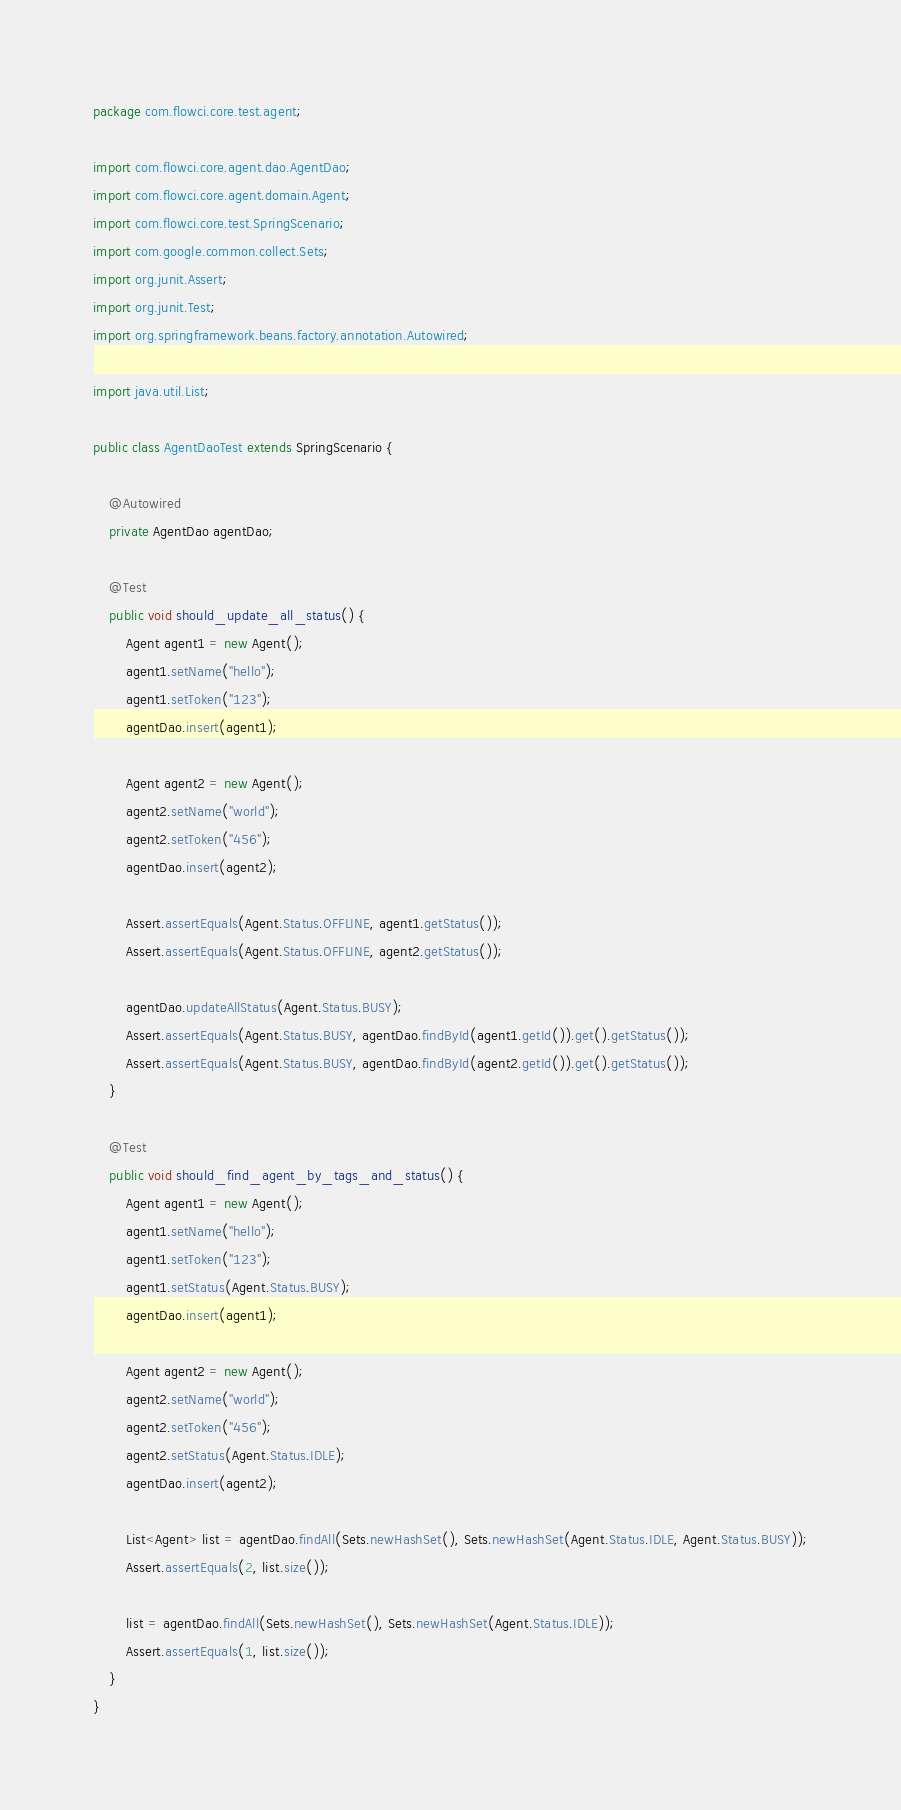Convert code to text. <code><loc_0><loc_0><loc_500><loc_500><_Java_>package com.flowci.core.test.agent;

import com.flowci.core.agent.dao.AgentDao;
import com.flowci.core.agent.domain.Agent;
import com.flowci.core.test.SpringScenario;
import com.google.common.collect.Sets;
import org.junit.Assert;
import org.junit.Test;
import org.springframework.beans.factory.annotation.Autowired;

import java.util.List;

public class AgentDaoTest extends SpringScenario {

    @Autowired
    private AgentDao agentDao;

    @Test
    public void should_update_all_status() {
        Agent agent1 = new Agent();
        agent1.setName("hello");
        agent1.setToken("123");
        agentDao.insert(agent1);

        Agent agent2 = new Agent();
        agent2.setName("world");
        agent2.setToken("456");
        agentDao.insert(agent2);

        Assert.assertEquals(Agent.Status.OFFLINE, agent1.getStatus());
        Assert.assertEquals(Agent.Status.OFFLINE, agent2.getStatus());

        agentDao.updateAllStatus(Agent.Status.BUSY);
        Assert.assertEquals(Agent.Status.BUSY, agentDao.findById(agent1.getId()).get().getStatus());
        Assert.assertEquals(Agent.Status.BUSY, agentDao.findById(agent2.getId()).get().getStatus());
    }

    @Test
    public void should_find_agent_by_tags_and_status() {
        Agent agent1 = new Agent();
        agent1.setName("hello");
        agent1.setToken("123");
        agent1.setStatus(Agent.Status.BUSY);
        agentDao.insert(agent1);

        Agent agent2 = new Agent();
        agent2.setName("world");
        agent2.setToken("456");
        agent2.setStatus(Agent.Status.IDLE);
        agentDao.insert(agent2);

        List<Agent> list = agentDao.findAll(Sets.newHashSet(), Sets.newHashSet(Agent.Status.IDLE, Agent.Status.BUSY));
        Assert.assertEquals(2, list.size());

        list = agentDao.findAll(Sets.newHashSet(), Sets.newHashSet(Agent.Status.IDLE));
        Assert.assertEquals(1, list.size());
    }
}
</code> 